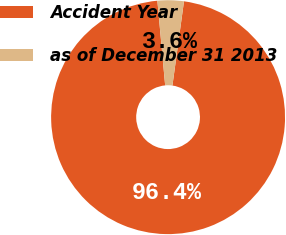Convert chart. <chart><loc_0><loc_0><loc_500><loc_500><pie_chart><fcel>Accident Year<fcel>as of December 31 2013<nl><fcel>96.37%<fcel>3.63%<nl></chart> 